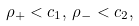Convert formula to latex. <formula><loc_0><loc_0><loc_500><loc_500>\rho _ { + } < c _ { 1 } , \, \rho _ { - } < c _ { 2 } ,</formula> 